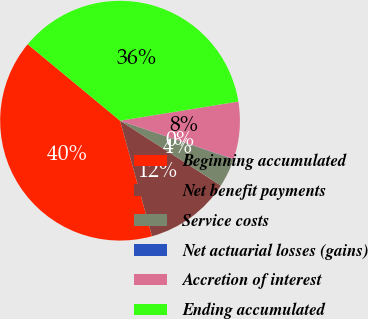<chart> <loc_0><loc_0><loc_500><loc_500><pie_chart><fcel>Beginning accumulated<fcel>Net benefit payments<fcel>Service costs<fcel>Net actuarial losses (gains)<fcel>Accretion of interest<fcel>Ending accumulated<nl><fcel>40.3%<fcel>11.6%<fcel>3.89%<fcel>0.03%<fcel>7.74%<fcel>36.44%<nl></chart> 